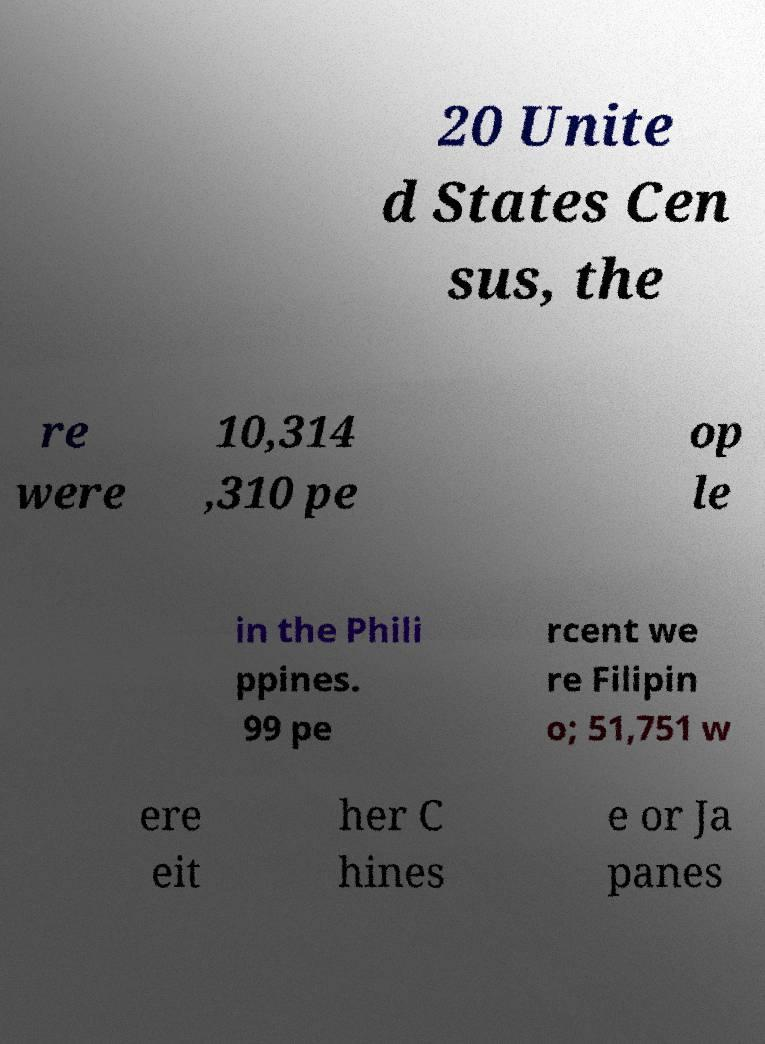There's text embedded in this image that I need extracted. Can you transcribe it verbatim? 20 Unite d States Cen sus, the re were 10,314 ,310 pe op le in the Phili ppines. 99 pe rcent we re Filipin o; 51,751 w ere eit her C hines e or Ja panes 